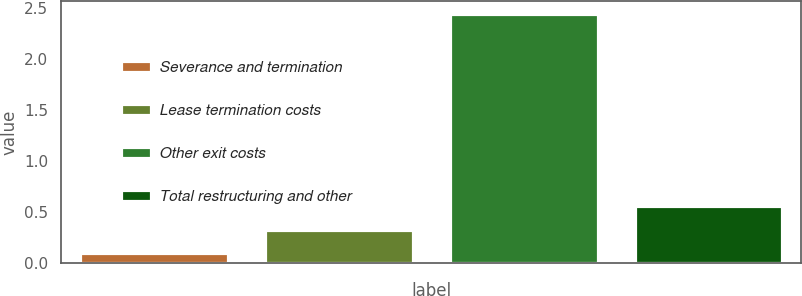<chart> <loc_0><loc_0><loc_500><loc_500><bar_chart><fcel>Severance and termination<fcel>Lease termination costs<fcel>Other exit costs<fcel>Total restructuring and other<nl><fcel>0.1<fcel>0.33<fcel>2.44<fcel>0.56<nl></chart> 